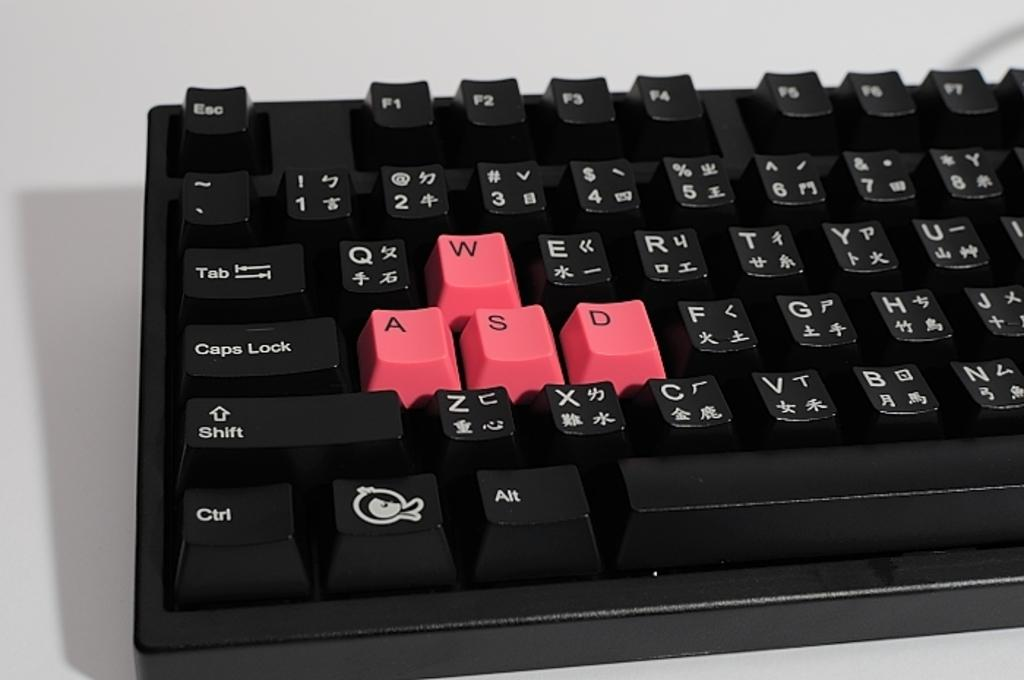<image>
Share a concise interpretation of the image provided. Black keyboard with pink keys which are the WASD keys. 